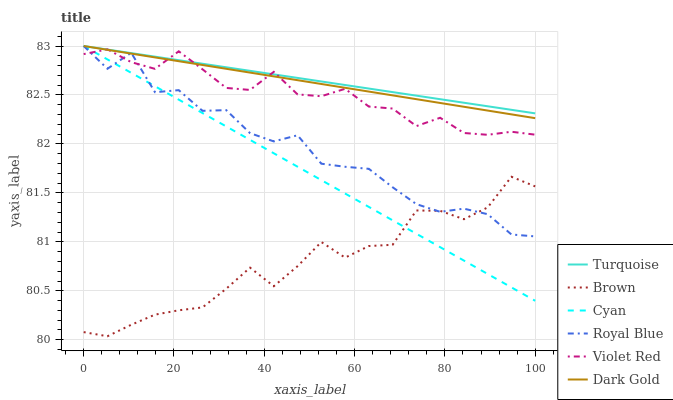Does Brown have the minimum area under the curve?
Answer yes or no. Yes. Does Turquoise have the maximum area under the curve?
Answer yes or no. Yes. Does Dark Gold have the minimum area under the curve?
Answer yes or no. No. Does Dark Gold have the maximum area under the curve?
Answer yes or no. No. Is Dark Gold the smoothest?
Answer yes or no. Yes. Is Royal Blue the roughest?
Answer yes or no. Yes. Is Turquoise the smoothest?
Answer yes or no. No. Is Turquoise the roughest?
Answer yes or no. No. Does Dark Gold have the lowest value?
Answer yes or no. No. Does Violet Red have the highest value?
Answer yes or no. No. Is Brown less than Dark Gold?
Answer yes or no. Yes. Is Dark Gold greater than Brown?
Answer yes or no. Yes. Does Brown intersect Dark Gold?
Answer yes or no. No. 